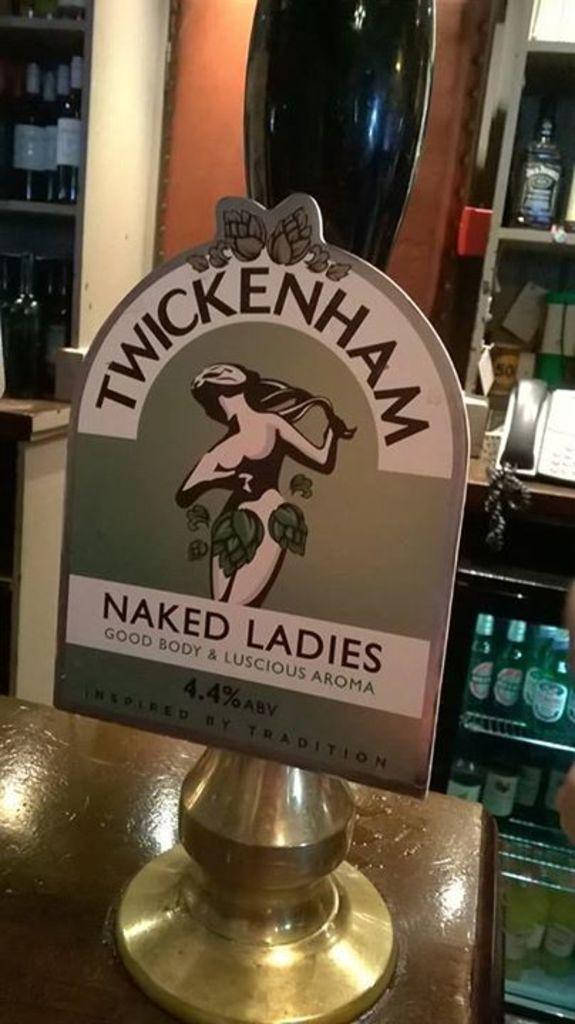<image>
Write a terse but informative summary of the picture. A Pub has Twickenham Naked Ladies Ale on tap. 